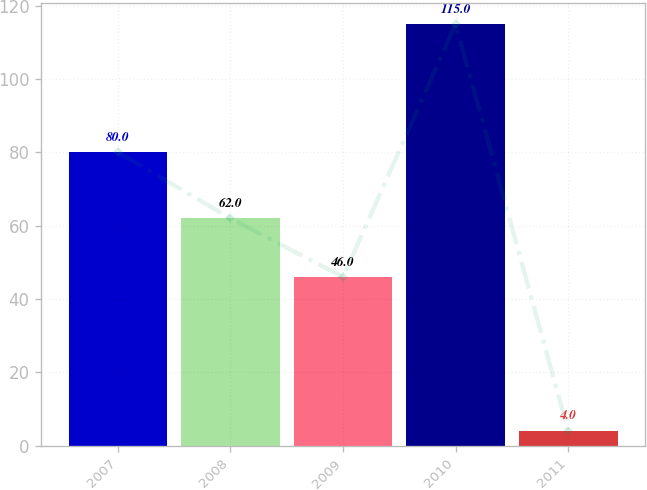Convert chart. <chart><loc_0><loc_0><loc_500><loc_500><bar_chart><fcel>2007<fcel>2008<fcel>2009<fcel>2010<fcel>2011<nl><fcel>80<fcel>62<fcel>46<fcel>115<fcel>4<nl></chart> 